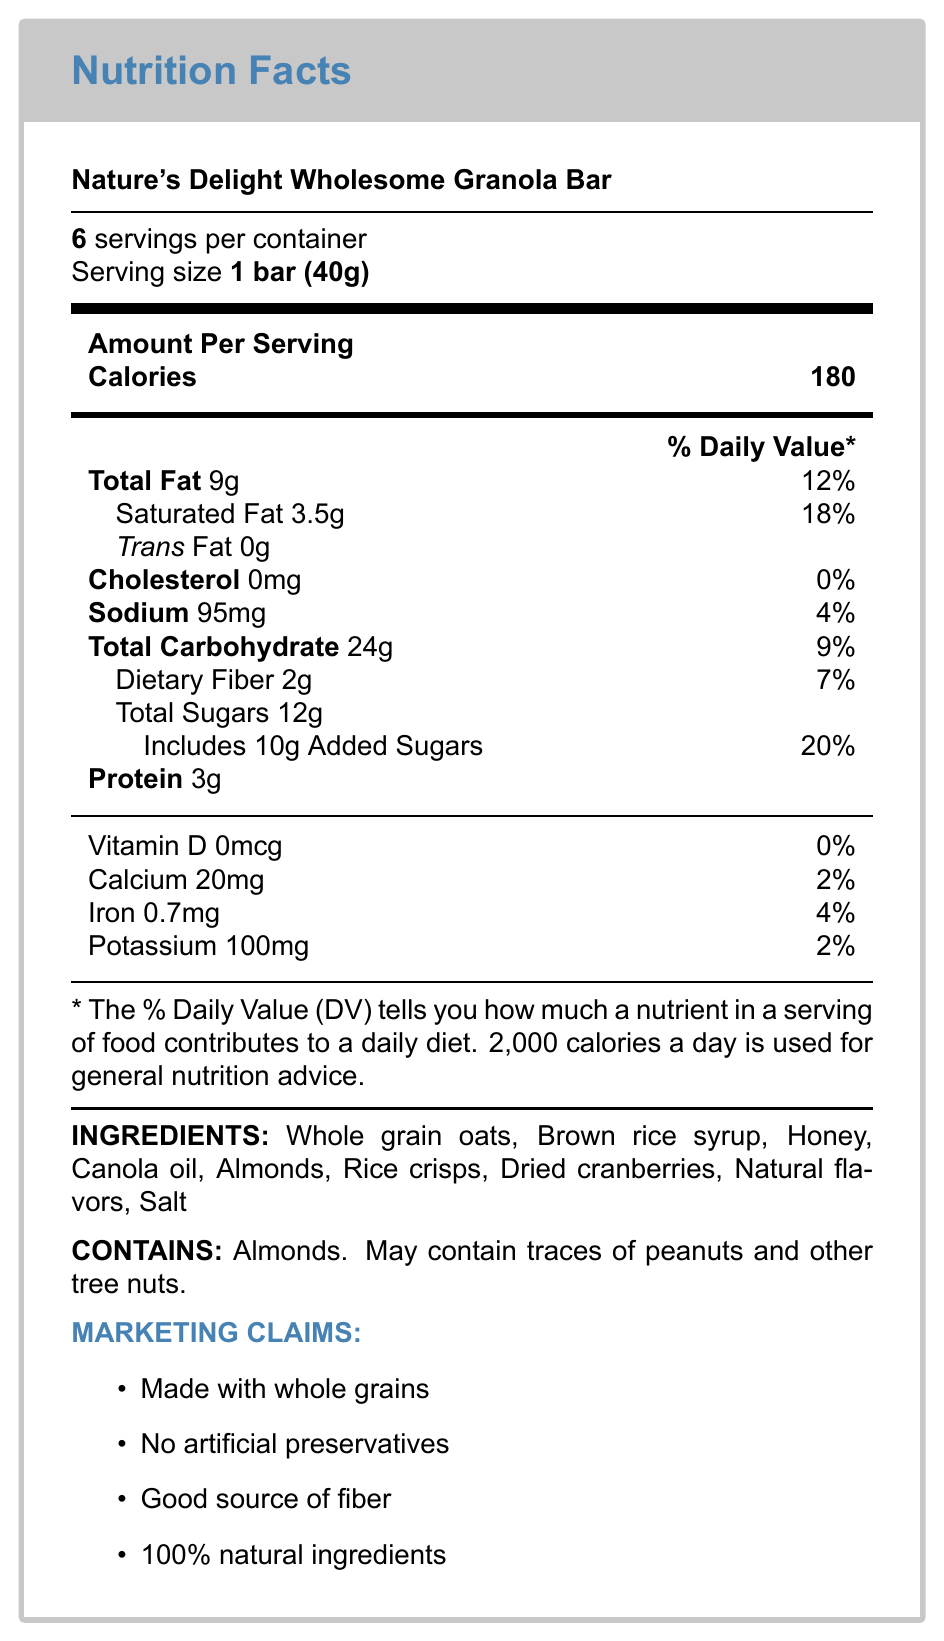what is the serving size for the Nature's Delight Wholesome Granola Bar? The serving size is mentioned as "1 bar (40g)" directly under the product name in the Nutrition Facts label.
Answer: 1 bar (40g) how many calories are in one serving? The label clearly states "Calories 180" in the Amount Per Serving section.
Answer: 180 calories what is the total fat content per serving and its percentage of Daily Value? The label indicates that one serving contains 9g of total fat, which is 12% of the Daily Value.
Answer: 9g, 12% what are the main sources of sugar in the granola bar? The ingredients list shows that Brown rice syrup and Honey are the main sources of sugar.
Answer: Brown rice syrup, Honey how much protein is in one serving? The Nutrition Facts label shows that each serving contains 3g of protein.
Answer: 3g which nutrient contributes to 20% of the Daily Value? The label specifies that "Includes 10g Added Sugars" which is 20% of the Daily Value.
Answer: Added Sugars what percentage of Daily Value (%DV) is the sodium content? A. 2% B. 4% C. 8% The label states that the sodium content is 95mg, which is 4% of the Daily Value.
Answer: B. 4% how many servings are there per container? A. 4 B. 6 C. 8 D. 10 At the top of the label, it states "6 servings per container."
Answer: B. 6 is the granola bar cholesterol-free? Yes/No The label shows "Cholesterol 0mg" with a Daily Value of 0%.
Answer: Yes summarize the main marketing claims made about the granola bar. These marketing claims are listed at the bottom of the Nutrition Facts label under the Marketing Claims section.
Answer: The granola bar claims to be made with whole grains, contain no artificial preservatives, be a good source of fiber, and have 100% natural ingredients. how much iron does the granola bar provide per serving? The Nutrition Facts label lists iron content as 0.7mg per serving.
Answer: 0.7mg what is the total carbohydrate content per serving? The label indicates a total carbohydrate content of 24g per serving.
Answer: 24g what information is missing about the product's manufacturing details? The document doesn't provide any information about the product's manufacturing details such as where it is produced or any certifications.
Answer: Cannot be determined which ingredients suggest the bar has a high sugar content despite seeming healthful? The ingredients include Brown rice syrup, Honey, and Dried cranberries, all of which contribute to the high sugar content.
Answer: Brown rice syrup, Honey, Dried cranberries what tactic is used in the product name to imply healthiness? The document lists "Using 'Nature's Delight' in the name to imply healthiness" as a manipulative tactic.
Answer: Using "Nature's Delight" 